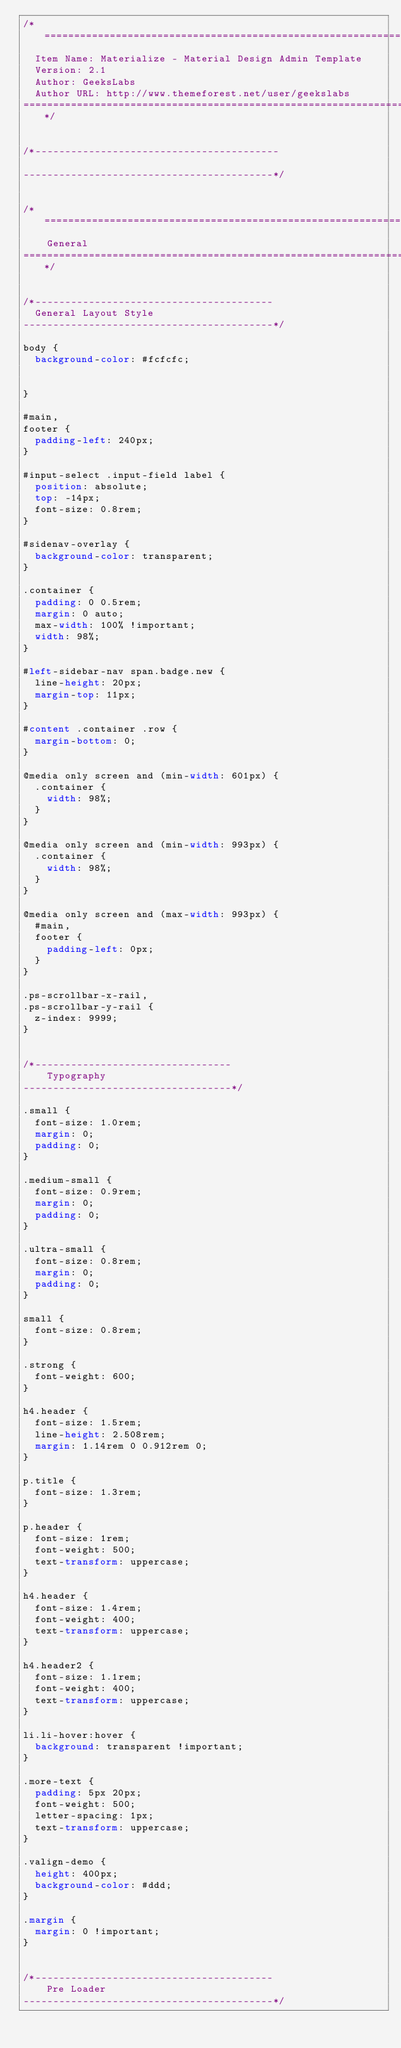<code> <loc_0><loc_0><loc_500><loc_500><_CSS_>/*================================================================================
  Item Name: Materialize - Material Design Admin Template
  Version: 2.1
  Author: GeeksLabs
  Author URL: http://www.themeforest.net/user/geekslabs
================================================================================*/


/*-----------------------------------------

------------------------------------------*/


/*=================================================================================
    General
====================================================================================*/


/*----------------------------------------
  General Layout Style
------------------------------------------*/

body {
  background-color: #fcfcfc;


}

#main,
footer {
  padding-left: 240px;
}

#input-select .input-field label {
  position: absolute;
  top: -14px;
  font-size: 0.8rem;
}

#sidenav-overlay {
  background-color: transparent;
}

.container {
  padding: 0 0.5rem;
  margin: 0 auto;
  max-width: 100% !important;
  width: 98%;
}

#left-sidebar-nav span.badge.new {
  line-height: 20px;
  margin-top: 11px;
}

#content .container .row {
  margin-bottom: 0;
}

@media only screen and (min-width: 601px) {
  .container {
    width: 98%;
  }
}

@media only screen and (min-width: 993px) {
  .container {
    width: 98%;
  }
}

@media only screen and (max-width: 993px) {
  #main,
  footer {
    padding-left: 0px;
  }
}

.ps-scrollbar-x-rail,
.ps-scrollbar-y-rail {
  z-index: 9999;
}


/*---------------------------------
    Typography
-----------------------------------*/

.small {
  font-size: 1.0rem;
  margin: 0;
  padding: 0;
}

.medium-small {
  font-size: 0.9rem;
  margin: 0;
  padding: 0;
}

.ultra-small {
  font-size: 0.8rem;
  margin: 0;
  padding: 0;
}

small {
  font-size: 0.8rem;
}

.strong {
  font-weight: 600;
}

h4.header {
  font-size: 1.5rem;
  line-height: 2.508rem;
  margin: 1.14rem 0 0.912rem 0;
}

p.title {
  font-size: 1.3rem;
}

p.header {
  font-size: 1rem;
  font-weight: 500;
  text-transform: uppercase;
}

h4.header {
  font-size: 1.4rem;
  font-weight: 400;
  text-transform: uppercase;
}

h4.header2 {
  font-size: 1.1rem;
  font-weight: 400;
  text-transform: uppercase;
}

li.li-hover:hover {
  background: transparent !important;
}

.more-text {
  padding: 5px 20px;
  font-weight: 500;
  letter-spacing: 1px;
  text-transform: uppercase;
}

.valign-demo {
  height: 400px;
  background-color: #ddd;
}

.margin {
  margin: 0 !important;
}


/*----------------------------------------
    Pre Loader
------------------------------------------*/
</code> 